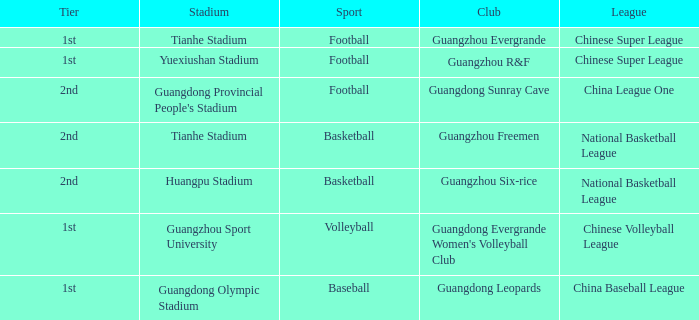Which tier is for football at Tianhe Stadium? 1st. 